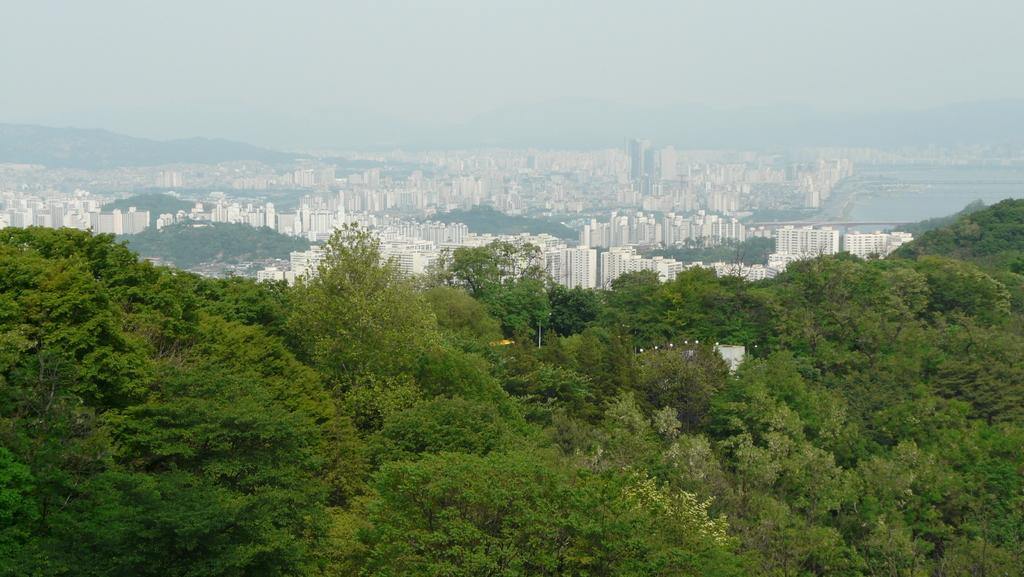What type of natural elements can be seen in the image? There are many trees in the image. What type of man-made structures are visible in the background? There are buildings in the background of the image. What part of the natural environment is visible in the image? The sky is visible in the image. What type of substance is the beggar using to clean the button in the image? There is no beggar or button present in the image. 